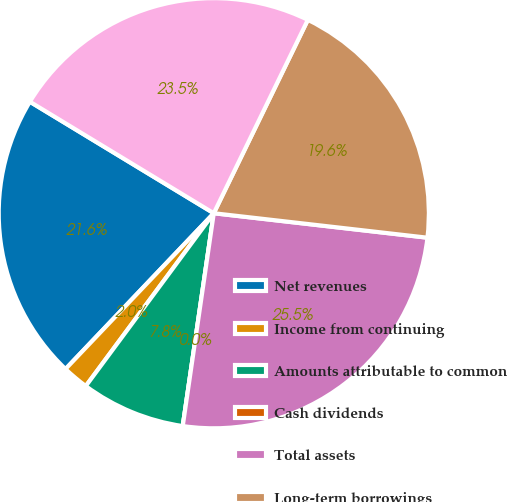Convert chart to OTSL. <chart><loc_0><loc_0><loc_500><loc_500><pie_chart><fcel>Net revenues<fcel>Income from continuing<fcel>Amounts attributable to common<fcel>Cash dividends<fcel>Total assets<fcel>Long-term borrowings<fcel>Shareholders' equity<nl><fcel>21.57%<fcel>1.96%<fcel>7.84%<fcel>0.0%<fcel>25.49%<fcel>19.61%<fcel>23.53%<nl></chart> 